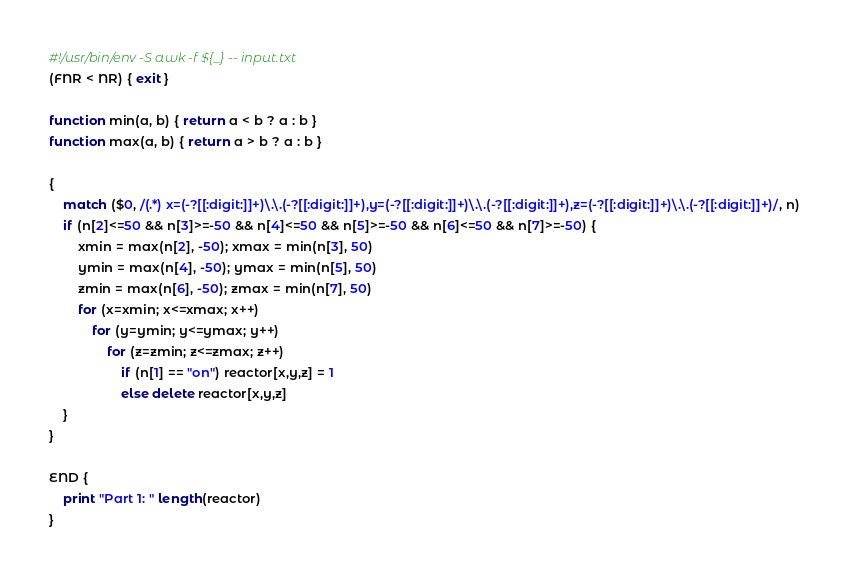<code> <loc_0><loc_0><loc_500><loc_500><_Awk_>#!/usr/bin/env -S awk -f ${_} -- input.txt
(FNR < NR) { exit }

function min(a, b) { return a < b ? a : b }
function max(a, b) { return a > b ? a : b }

{
    match ($0, /(.*) x=(-?[[:digit:]]+)\.\.(-?[[:digit:]]+),y=(-?[[:digit:]]+)\.\.(-?[[:digit:]]+),z=(-?[[:digit:]]+)\.\.(-?[[:digit:]]+)/, n)
    if (n[2]<=50 && n[3]>=-50 && n[4]<=50 && n[5]>=-50 && n[6]<=50 && n[7]>=-50) {
        xmin = max(n[2], -50); xmax = min(n[3], 50)
        ymin = max(n[4], -50); ymax = min(n[5], 50)
        zmin = max(n[6], -50); zmax = min(n[7], 50)
        for (x=xmin; x<=xmax; x++)
            for (y=ymin; y<=ymax; y++)
                for (z=zmin; z<=zmax; z++)
                    if (n[1] == "on") reactor[x,y,z] = 1
                    else delete reactor[x,y,z]
    }
}

END {
    print "Part 1: " length(reactor)
}
</code> 